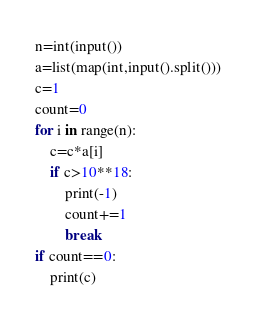<code> <loc_0><loc_0><loc_500><loc_500><_Python_>n=int(input())
a=list(map(int,input().split()))
c=1
count=0
for i in range(n):
    c=c*a[i]
    if c>10**18:
        print(-1)
        count+=1
        break
if count==0:
    print(c)</code> 